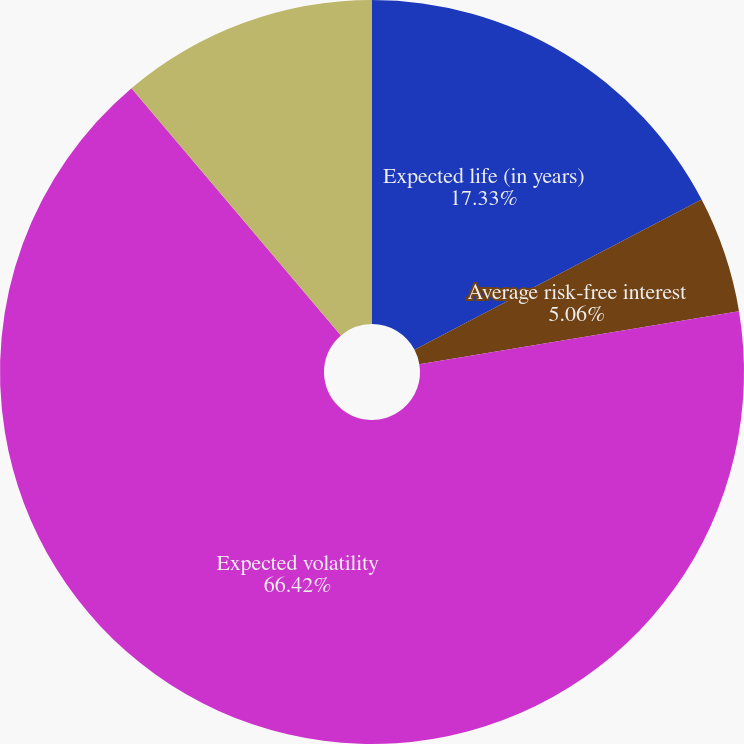<chart> <loc_0><loc_0><loc_500><loc_500><pie_chart><fcel>Expected life (in years)<fcel>Average risk-free interest<fcel>Expected volatility<fcel>Expected dividend yield<nl><fcel>17.33%<fcel>5.06%<fcel>66.42%<fcel>11.19%<nl></chart> 